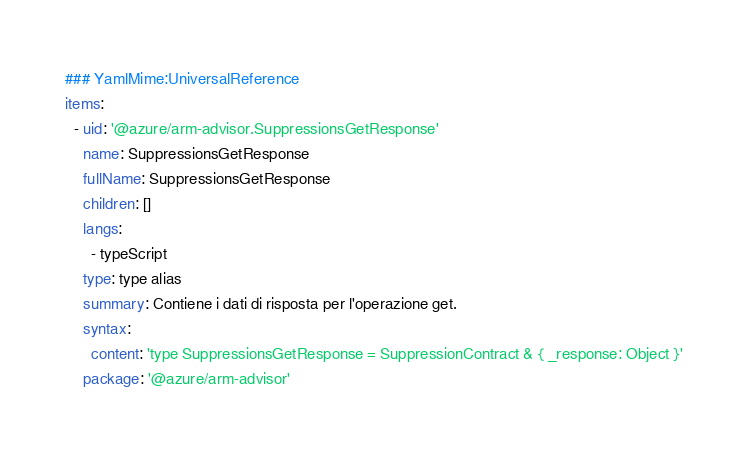Convert code to text. <code><loc_0><loc_0><loc_500><loc_500><_YAML_>### YamlMime:UniversalReference
items:
  - uid: '@azure/arm-advisor.SuppressionsGetResponse'
    name: SuppressionsGetResponse
    fullName: SuppressionsGetResponse
    children: []
    langs:
      - typeScript
    type: type alias
    summary: Contiene i dati di risposta per l'operazione get.
    syntax:
      content: 'type SuppressionsGetResponse = SuppressionContract & { _response: Object }'
    package: '@azure/arm-advisor'</code> 